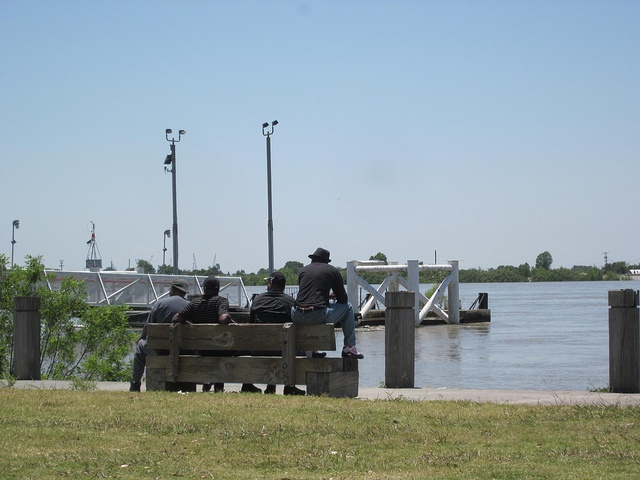Describe the objects in this image and their specific colors. I can see bench in lightblue, black, and gray tones, people in lightblue, black, gray, and darkblue tones, people in lightblue, black, and gray tones, people in lightblue, black, and gray tones, and people in lightblue, black, gray, and darkgray tones in this image. 